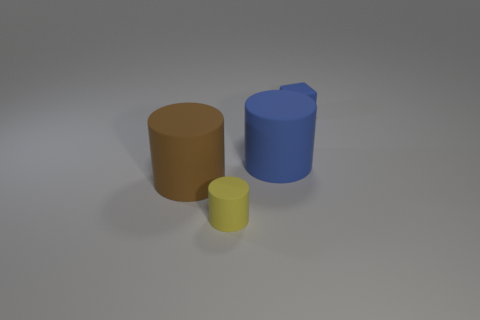Subtract all big matte cylinders. How many cylinders are left? 1 Add 3 small blocks. How many objects exist? 7 Subtract 1 cylinders. How many cylinders are left? 2 Add 3 tiny yellow rubber cylinders. How many tiny yellow rubber cylinders exist? 4 Subtract all yellow cylinders. How many cylinders are left? 2 Subtract 0 green blocks. How many objects are left? 4 Subtract all cylinders. How many objects are left? 1 Subtract all purple cylinders. Subtract all purple cubes. How many cylinders are left? 3 Subtract all blue cylinders. How many brown cubes are left? 0 Subtract all yellow objects. Subtract all small blue rubber blocks. How many objects are left? 2 